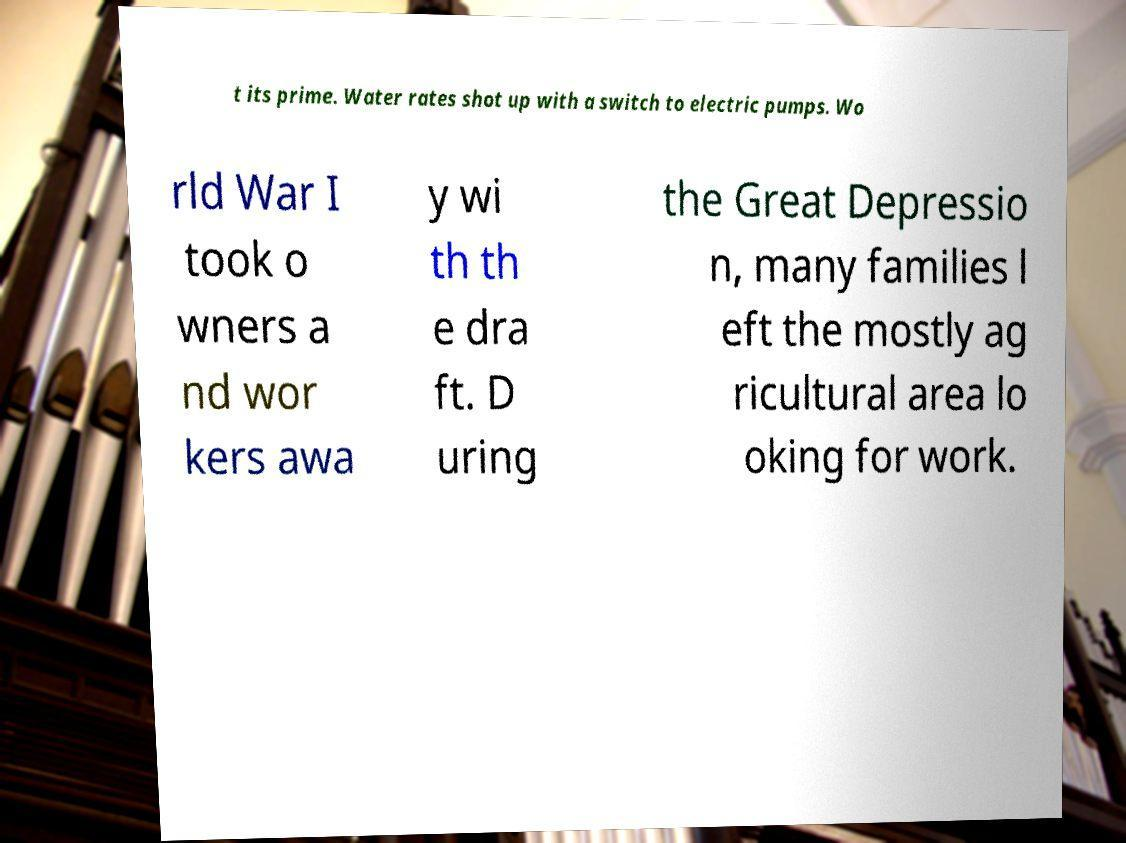Can you accurately transcribe the text from the provided image for me? t its prime. Water rates shot up with a switch to electric pumps. Wo rld War I took o wners a nd wor kers awa y wi th th e dra ft. D uring the Great Depressio n, many families l eft the mostly ag ricultural area lo oking for work. 